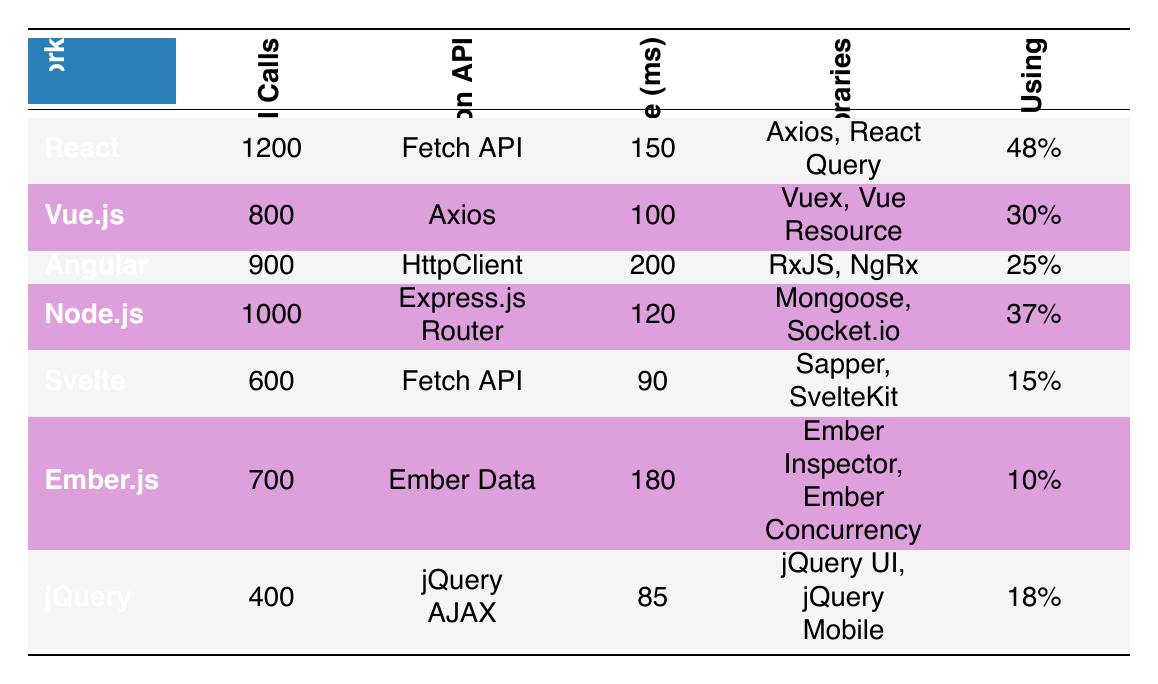What is the average number of API calls per app for React? The table shows that React has an average of 1200 API calls per app listed in the corresponding column.
Answer: 1200 Which framework has the highest percentage of developers using it? By comparing the percentages across the frameworks, React has the highest at 48%, more than any other listed framework.
Answer: React What is the most common API used in Angular? The table indicates that Angular uses HttpClient as its most common API, as shown in that specific row.
Answer: HttpClient Calculate the difference in average response time between Vue.js and Svelte. Vue.js has an average response time of 100 ms and Svelte has 90 ms. The difference is 100 - 90 = 10 ms.
Answer: 10 ms Is it true that jQuery has a lower average number of API calls than Ember.js? Looking at the table, jQuery has 400 API calls, while Ember.js has 700 API calls, confirming that jQuery has fewer calls.
Answer: Yes Find the framework with the longest average response time. By examining the avg response time column, Angular has the longest time at 200 ms, which is greater than the others.
Answer: Angular Which framework has the lowest percentage of developers using it and what is that percentage? The table shows that Ember.js has the lowest percentage at 10%, as noted in the corresponding column.
Answer: 10% Sum the average API calls for Node.js and Svelte. Node.js has 1000 API calls, and Svelte has 600 API calls. Together, that totals 1000 + 600 = 1600 API calls.
Answer: 1600 How many popular libraries does React have? React lists two popular libraries, Axios and React Query, in the table under its row.
Answer: 2 